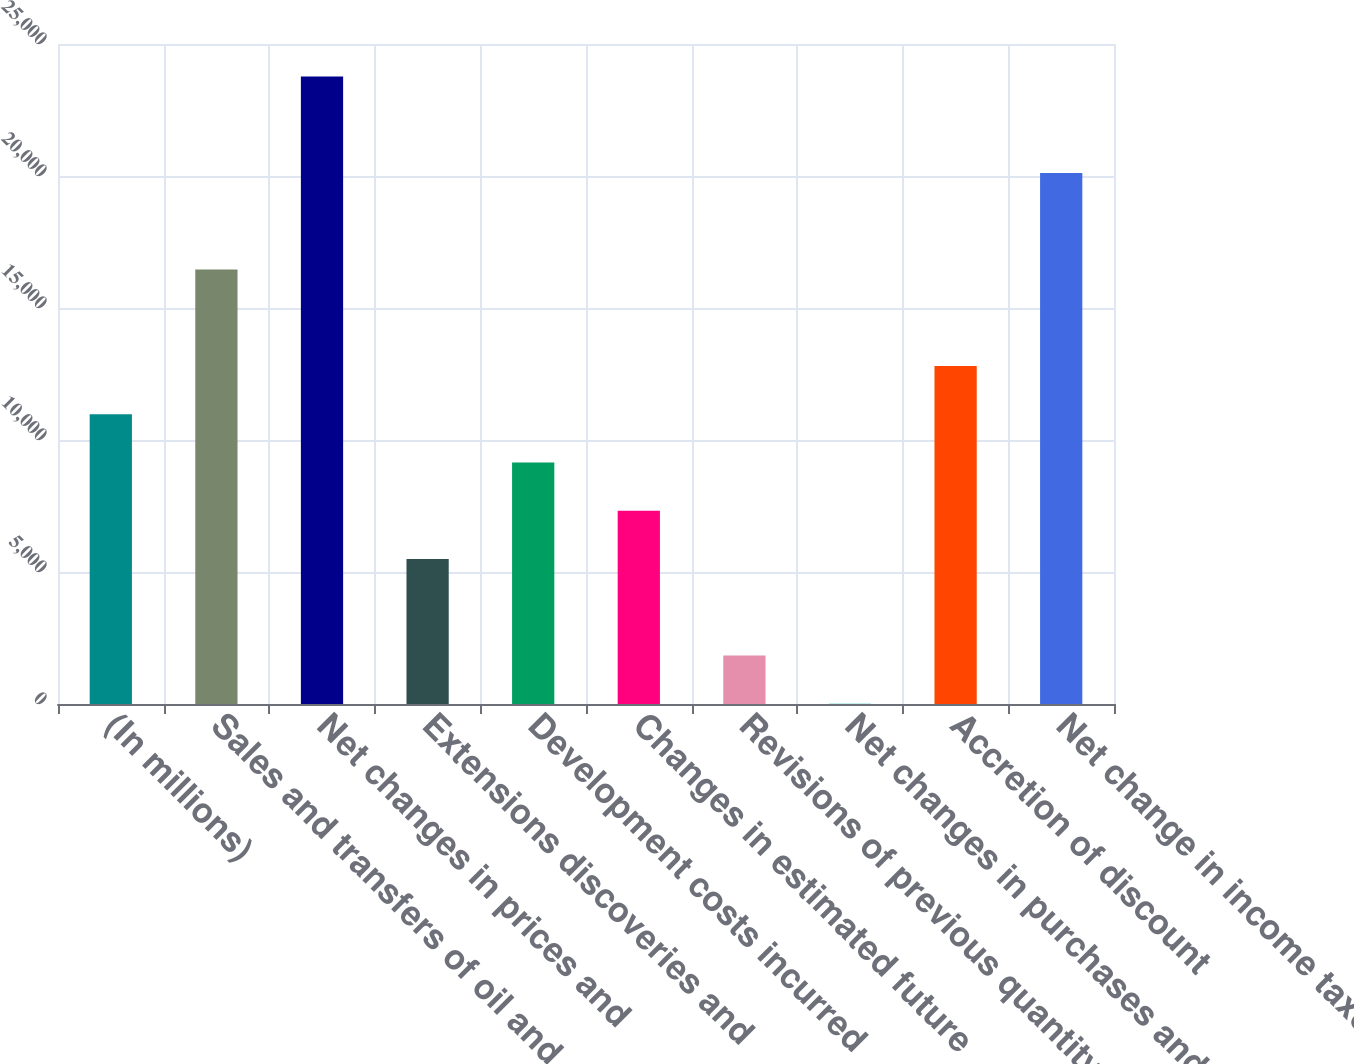Convert chart to OTSL. <chart><loc_0><loc_0><loc_500><loc_500><bar_chart><fcel>(In millions)<fcel>Sales and transfers of oil and<fcel>Net changes in prices and<fcel>Extensions discoveries and<fcel>Development costs incurred<fcel>Changes in estimated future<fcel>Revisions of previous quantity<fcel>Net changes in purchases and<fcel>Accretion of discount<fcel>Net change in income taxes<nl><fcel>10979.2<fcel>16462.3<fcel>23773.1<fcel>5496.1<fcel>9151.5<fcel>7323.8<fcel>1840.7<fcel>13<fcel>12806.9<fcel>20117.7<nl></chart> 